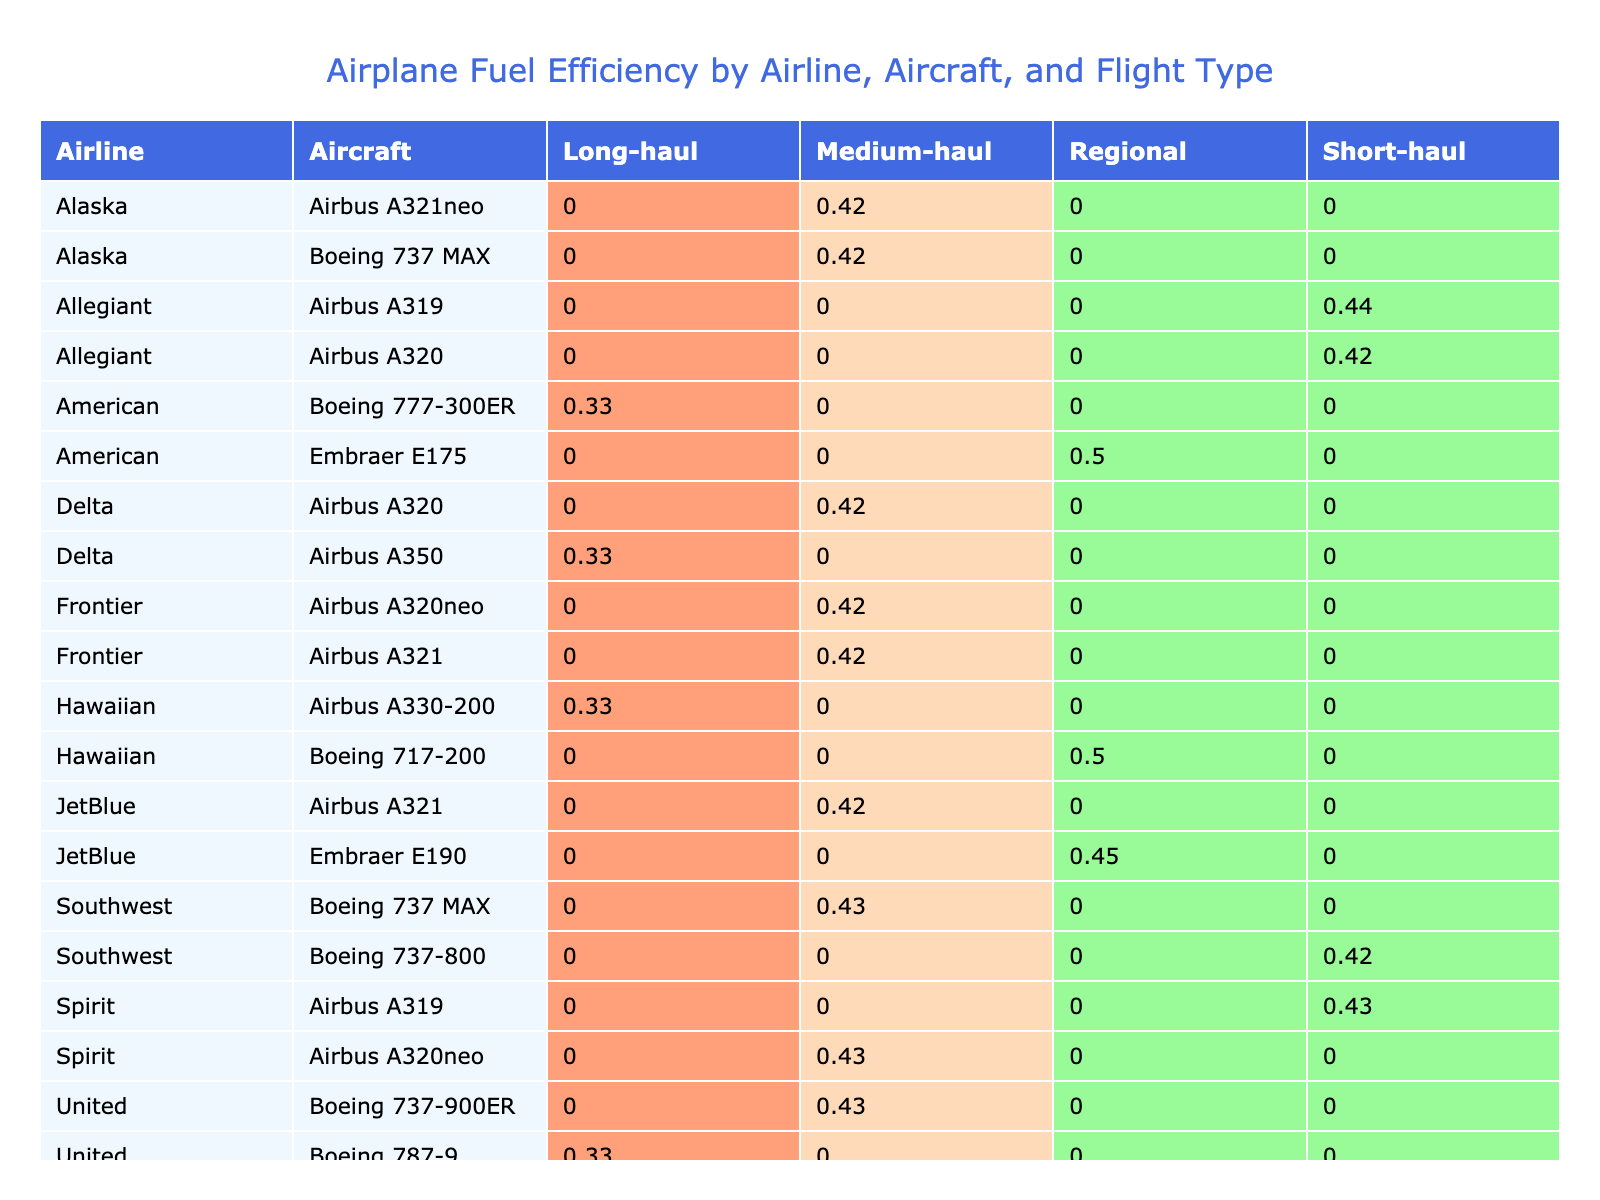What is the fuel efficiency of the Boeing 737-800 for short-haul flights? From the pivot table, we can see the Boeing 737-800 is listed under the "Southwest" airline and has a fuel efficiency value in the "Short-haul" column. By examining the table, we find that its fuel efficiency is 0.42 miles/gallon.
Answer: 0.42 Which aircraft type has the highest average fuel efficiency for long-haul flights? In the pivot table, we look at the long-haul column for each aircraft. The aircraft with the highest fuel efficiency listed is the Boeing 777-300ER, which has a value of 0.33 miles/gallon.
Answer: Boeing 777-300ER What is the average fuel efficiency of medium-haul flights across all aircraft? To find the average fuel efficiency for medium-haul flights, we sum the values in the medium-haul column: (0.38 + 0.42 + 0.41 + 0.40 + 0.42 + 0.37 + 0.42) = 2.62. We have 7 aircraft in medium-haul, so we divide the total by 7, resulting in an average of 2.62 / 7 ≈ 0.37 miles/gallon.
Answer: 0.37 Is the fuel efficiency for the Airbus A320 better for medium-haul flights compared to short-haul flights? The fuel efficiency for the Airbus A320 in medium-haul flights is 0.42 miles/gallon, while for short-haul flights, it is only 0.33 miles/gallon. Since 0.42 > 0.33, the efficiency of the Airbus A320 is indeed better for medium-haul.
Answer: Yes Which airline operates the most efficient aircraft for short-haul flights? Referencing the short-haul column, we see that the Allegiant Airbus A320 has the highest efficiency with 0.42 miles/gallon. Thus, Allegiant operates the most efficient aircraft for short-haul flights.
Answer: Allegiant What is the total fuel consumption for the medium-haul flights across all airlines? We need to sum up all the fuel consumption values listed for medium-haul flights: (1800 + 2400 + 3600 + 1900 + 4200 + 4800 + 3100) = 22800 gallons for all medium-haul flights combined.
Answer: 22800 Does the Delta airline operate any aircraft with a fuel efficiency above 0.40 miles/gallon for long-haul flights? Looking at Delta's long-haul aircraft, the Airbus A350 is listed with a fuel efficiency of 0.33 miles/gallon, which does not exceed 0.40. Therefore, Delta does not operate any aircraft above this efficiency for long-haul.
Answer: No Which aircraft has the best fuel efficiency for regional flights? In the regional flights section of the table, we can see the Embraer E175 has a fuel efficiency of 0.50 miles/gallon, which is the highest compared to other regional flights listed.
Answer: Embraer E175 